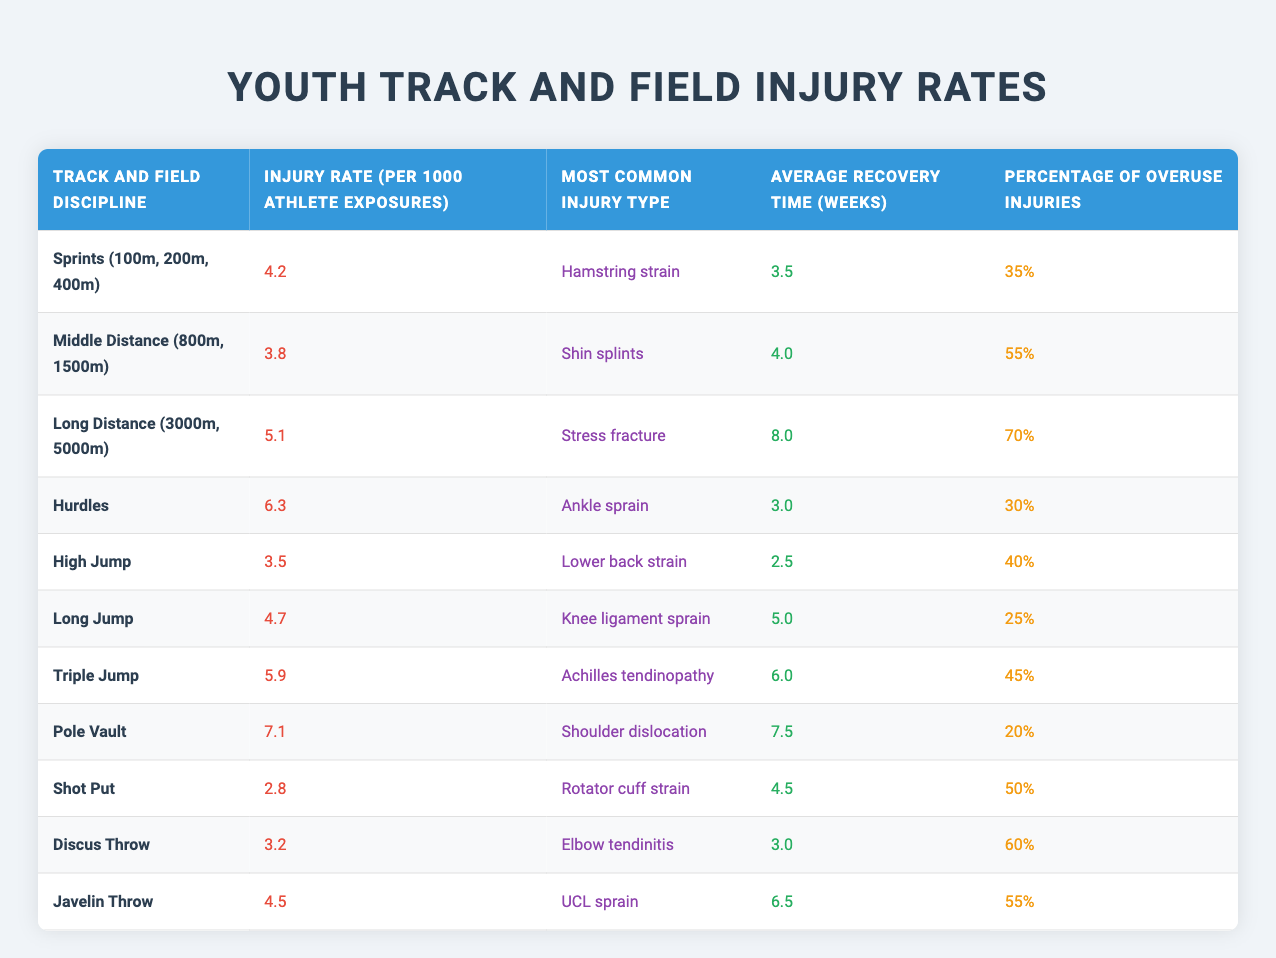What is the injury rate for Long Distance events? The injury rate for Long Distance (3000m, 5000m) events is listed in the table under the specific column which shows it is 5.1 per 1000 athlete exposures.
Answer: 5.1 Which discipline has the highest average recovery time? In the table, we look at the Recovery Time column and find that Long Distance has the highest average recovery time at 8 weeks.
Answer: 8 weeks What percentage of injuries in Middle Distance events are overuse injuries? Referring to the table, the Percentage of Overuse Injuries for Middle Distance (800m, 1500m) is clearly stated as 55%.
Answer: 55% Is the most common injury type in Hurdles an ankle sprain? By examining the Most Common Injury Type for Hurdles in the table, it is explicitly listed as an "Ankle sprain," confirming the statement as true.
Answer: Yes Which two disciplines have injury rates below 4 per 1000 athlete exposures? In the table, the injury rates indicate Shot Put at 2.8 and High Jump at 3.5; both are below 4. Therefore, these two disciplines fulfill the criteria.
Answer: Shot Put and High Jump What is the average injury rate of all jumping disciplines (High Jump, Long Jump, Triple Jump, and Pole Vault)? To find the average, we first identify the injury rates: High Jump (3.5), Long Jump (4.7), Triple Jump (5.9), and Pole Vault (7.1). We sum these values (3.5 + 4.7 + 5.9 + 7.1 = 21.2) and divide by 4 to find the average (21.2 / 4 = 5.3).
Answer: 5.3 What is the most common injury type for the discipline with the lowest injury rate? Looking at the table, the discipline with the lowest injury rate is Shot Put at 2.8, and the most common injury type as per the table is "Rotator cuff strain."
Answer: Rotator cuff strain Is the percentage of overuse injuries in Discus Throw higher than 50%? Checking the Percentage of Overuse Injuries in the table for Discus Throw, it is listed as 60%. Since 60% is indeed higher than 50%, the answer is true.
Answer: Yes What type of injury is most common in Long Jump? The table specifies that the most common injury type for Long Jump is "Knee ligament sprain," making this the correct answer.
Answer: Knee ligament sprain 